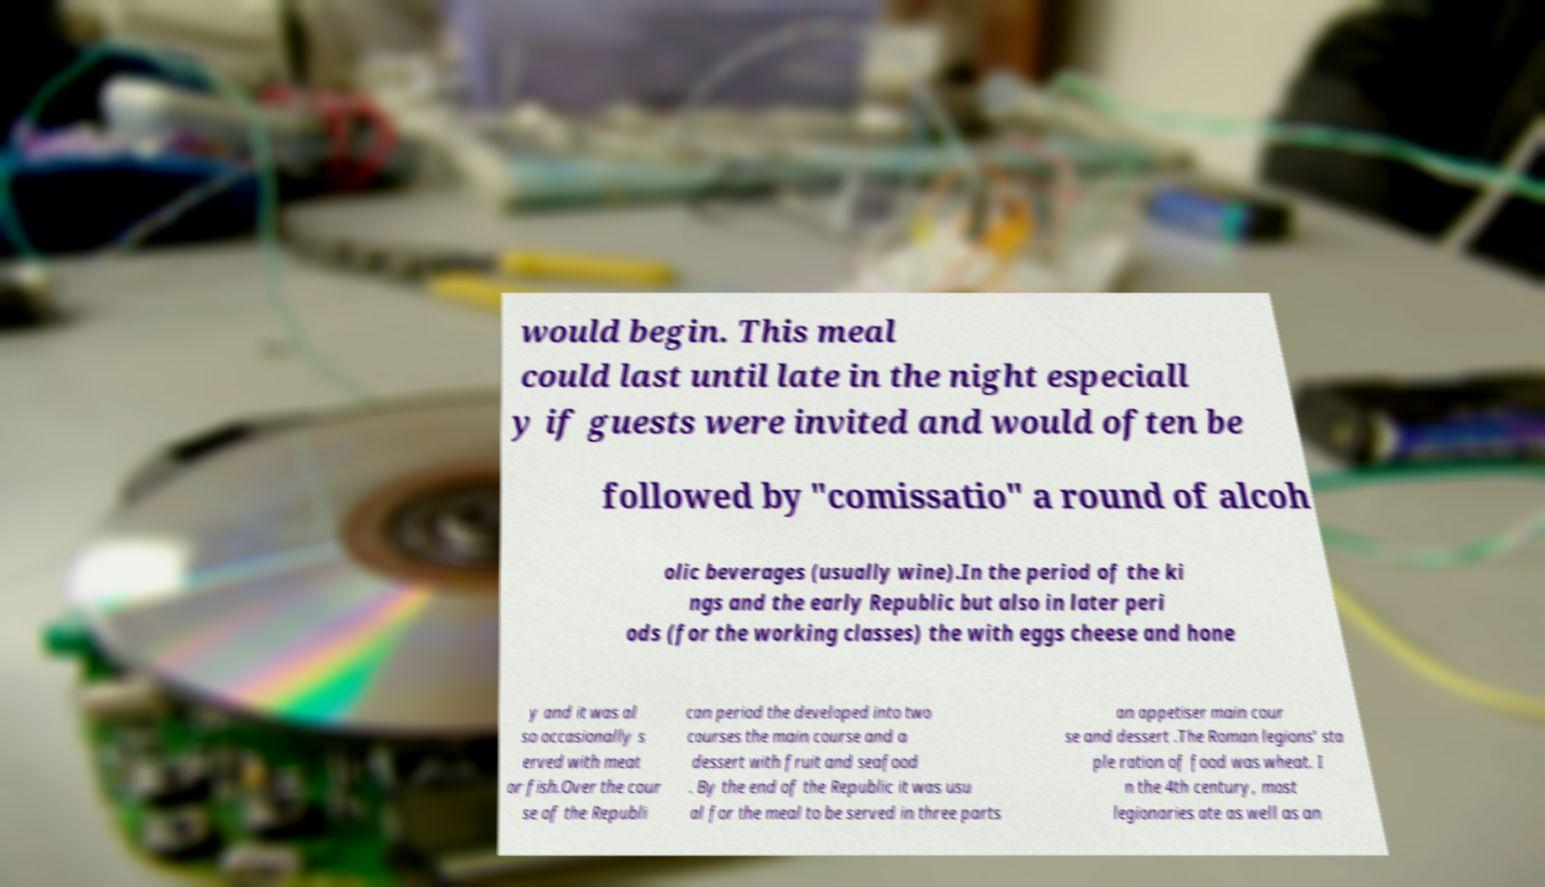There's text embedded in this image that I need extracted. Can you transcribe it verbatim? would begin. This meal could last until late in the night especiall y if guests were invited and would often be followed by "comissatio" a round of alcoh olic beverages (usually wine).In the period of the ki ngs and the early Republic but also in later peri ods (for the working classes) the with eggs cheese and hone y and it was al so occasionally s erved with meat or fish.Over the cour se of the Republi can period the developed into two courses the main course and a dessert with fruit and seafood . By the end of the Republic it was usu al for the meal to be served in three parts an appetiser main cour se and dessert .The Roman legions' sta ple ration of food was wheat. I n the 4th century, most legionaries ate as well as an 